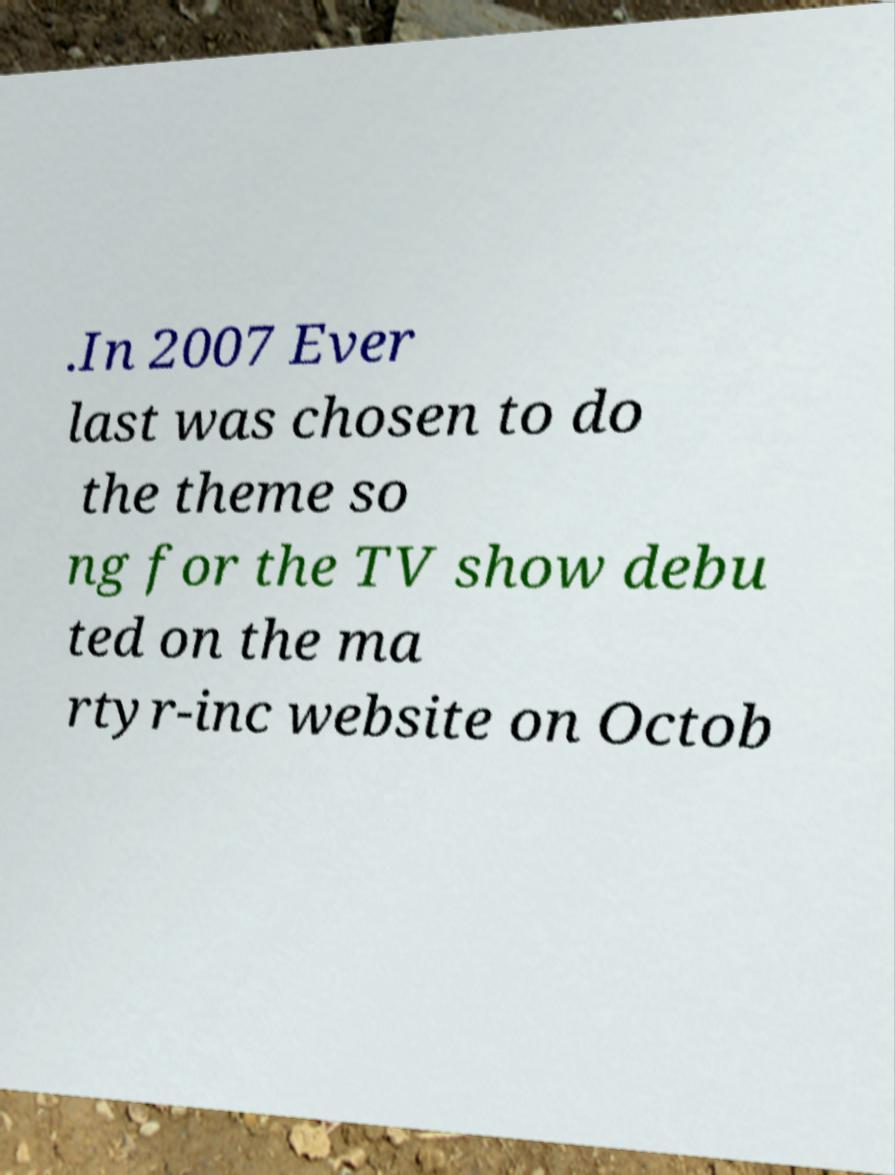Can you read and provide the text displayed in the image?This photo seems to have some interesting text. Can you extract and type it out for me? .In 2007 Ever last was chosen to do the theme so ng for the TV show debu ted on the ma rtyr-inc website on Octob 